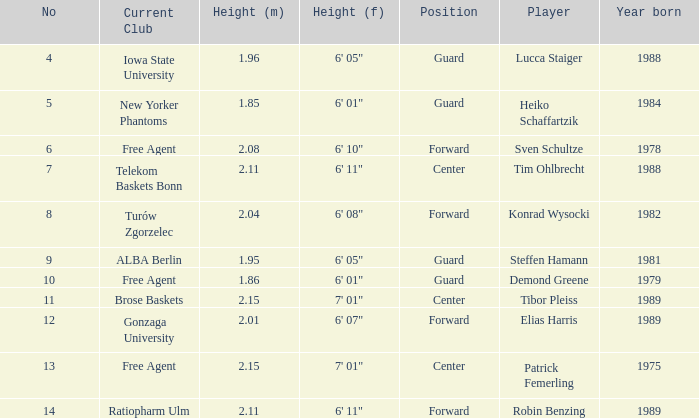Name the height of demond greene 6' 01". 